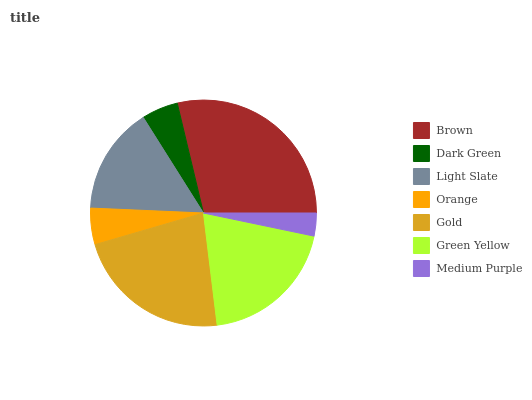Is Medium Purple the minimum?
Answer yes or no. Yes. Is Brown the maximum?
Answer yes or no. Yes. Is Dark Green the minimum?
Answer yes or no. No. Is Dark Green the maximum?
Answer yes or no. No. Is Brown greater than Dark Green?
Answer yes or no. Yes. Is Dark Green less than Brown?
Answer yes or no. Yes. Is Dark Green greater than Brown?
Answer yes or no. No. Is Brown less than Dark Green?
Answer yes or no. No. Is Light Slate the high median?
Answer yes or no. Yes. Is Light Slate the low median?
Answer yes or no. Yes. Is Orange the high median?
Answer yes or no. No. Is Green Yellow the low median?
Answer yes or no. No. 